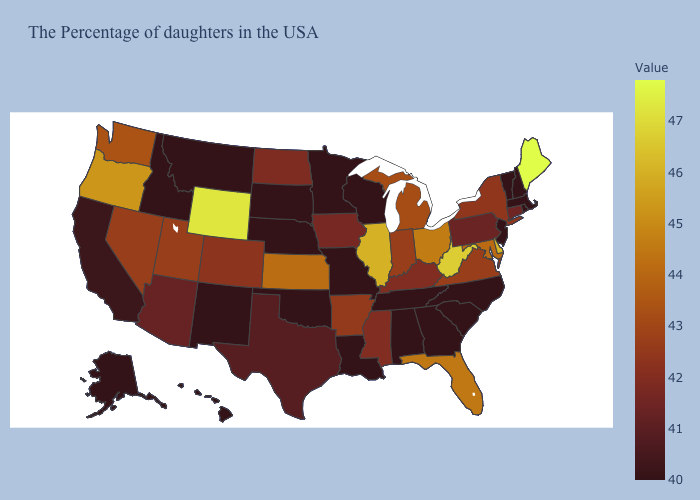Among the states that border Indiana , which have the highest value?
Answer briefly. Illinois. Does Delaware have a lower value than Wyoming?
Answer briefly. Yes. Among the states that border Mississippi , which have the highest value?
Give a very brief answer. Arkansas. Does Arkansas have a higher value than West Virginia?
Concise answer only. No. Among the states that border West Virginia , which have the highest value?
Give a very brief answer. Ohio. Does Hawaii have the lowest value in the USA?
Write a very short answer. Yes. Does Mississippi have a lower value than Ohio?
Write a very short answer. Yes. 